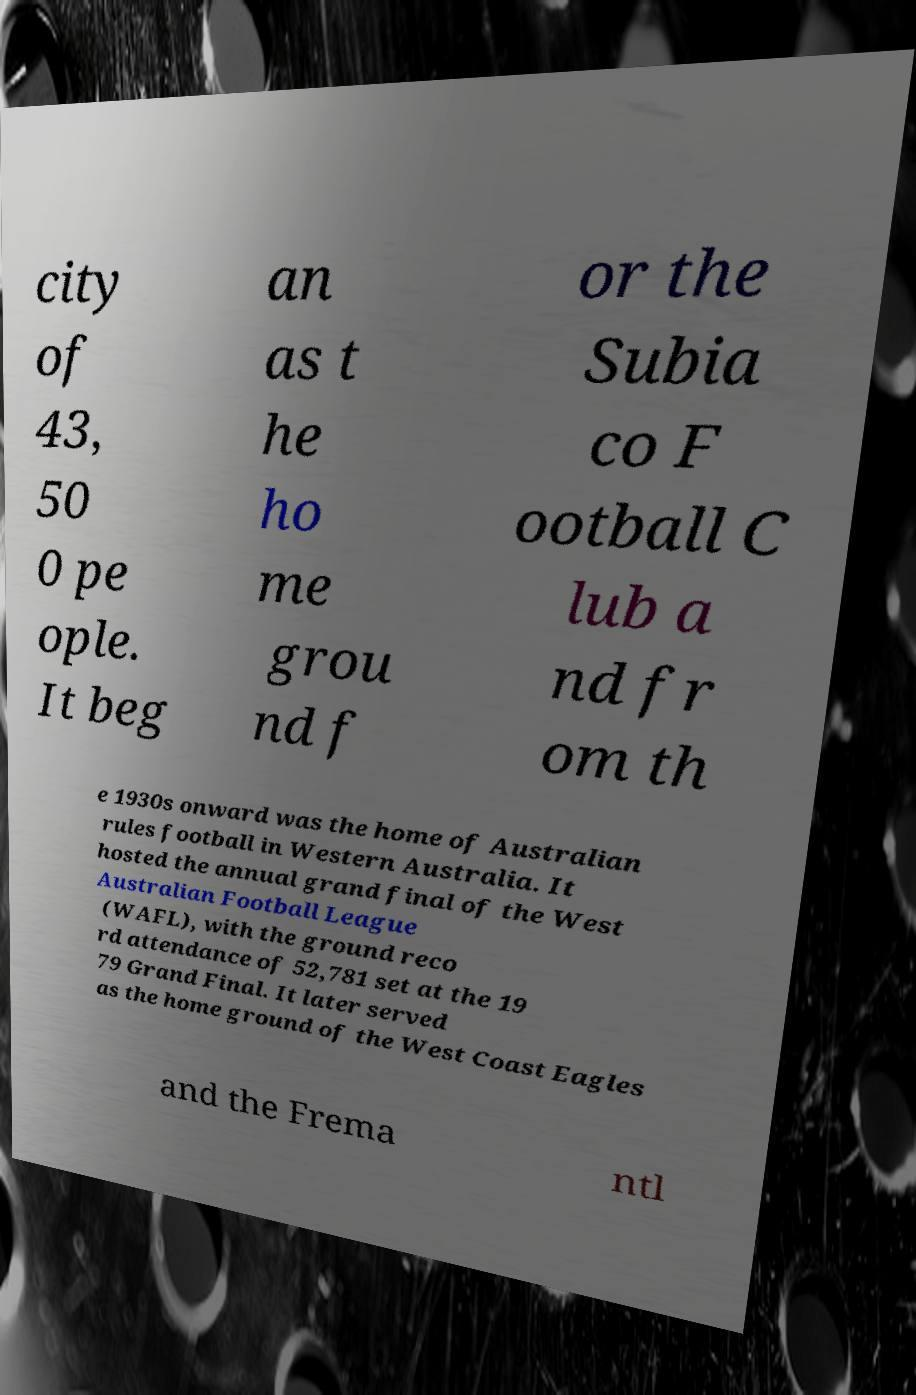Can you read and provide the text displayed in the image?This photo seems to have some interesting text. Can you extract and type it out for me? city of 43, 50 0 pe ople. It beg an as t he ho me grou nd f or the Subia co F ootball C lub a nd fr om th e 1930s onward was the home of Australian rules football in Western Australia. It hosted the annual grand final of the West Australian Football League (WAFL), with the ground reco rd attendance of 52,781 set at the 19 79 Grand Final. It later served as the home ground of the West Coast Eagles and the Frema ntl 